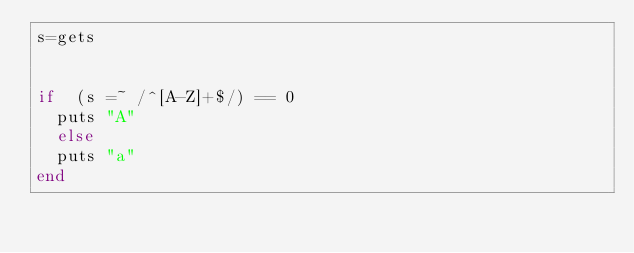Convert code to text. <code><loc_0><loc_0><loc_500><loc_500><_Ruby_>s=gets


if  (s =~ /^[A-Z]+$/) == 0 
  puts "A" 
  else
  puts "a"
end
</code> 